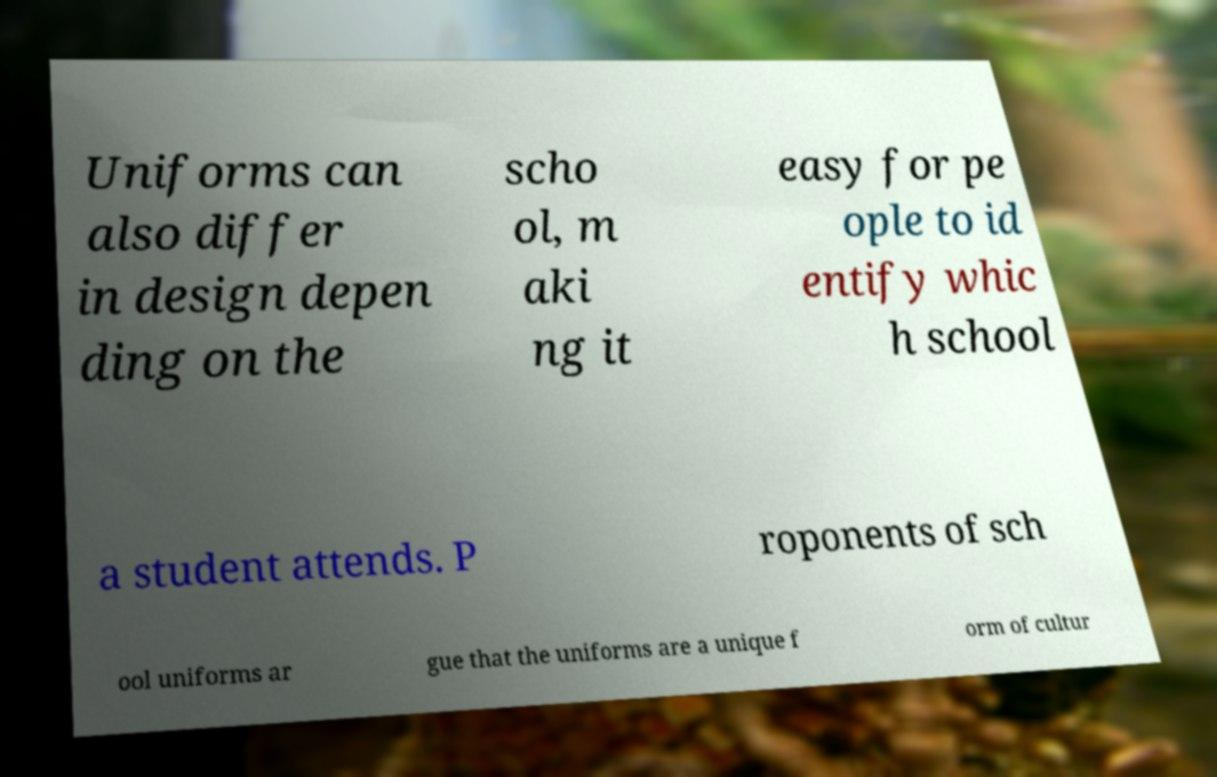There's text embedded in this image that I need extracted. Can you transcribe it verbatim? Uniforms can also differ in design depen ding on the scho ol, m aki ng it easy for pe ople to id entify whic h school a student attends. P roponents of sch ool uniforms ar gue that the uniforms are a unique f orm of cultur 